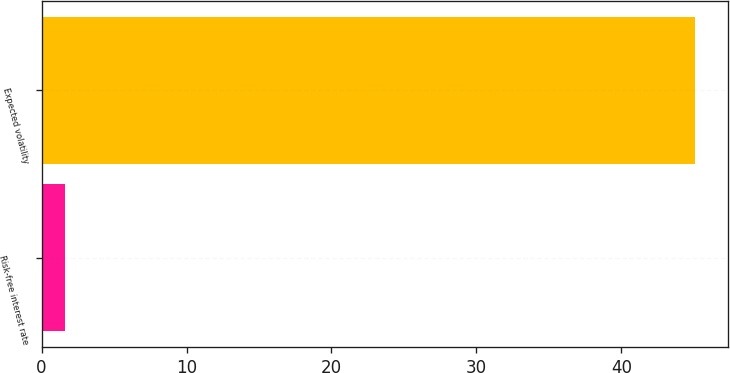Convert chart to OTSL. <chart><loc_0><loc_0><loc_500><loc_500><bar_chart><fcel>Risk-free interest rate<fcel>Expected volatility<nl><fcel>1.6<fcel>45.1<nl></chart> 